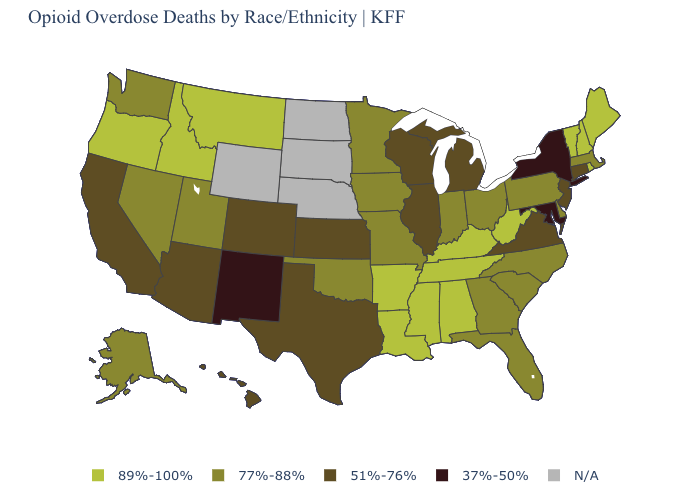Does Montana have the highest value in the West?
Be succinct. Yes. What is the value of Ohio?
Give a very brief answer. 77%-88%. What is the value of Massachusetts?
Write a very short answer. 77%-88%. What is the lowest value in the USA?
Write a very short answer. 37%-50%. Does the first symbol in the legend represent the smallest category?
Quick response, please. No. Does Maryland have the lowest value in the USA?
Concise answer only. Yes. Does New Mexico have the lowest value in the USA?
Write a very short answer. Yes. What is the value of Virginia?
Short answer required. 51%-76%. Which states have the highest value in the USA?
Answer briefly. Alabama, Arkansas, Idaho, Kentucky, Louisiana, Maine, Mississippi, Montana, New Hampshire, Oregon, Rhode Island, Tennessee, Vermont, West Virginia. Among the states that border Kansas , which have the lowest value?
Give a very brief answer. Colorado. Name the states that have a value in the range 37%-50%?
Give a very brief answer. Maryland, New Mexico, New York. Name the states that have a value in the range N/A?
Give a very brief answer. Nebraska, North Dakota, South Dakota, Wyoming. Does the map have missing data?
Write a very short answer. Yes. Name the states that have a value in the range N/A?
Concise answer only. Nebraska, North Dakota, South Dakota, Wyoming. 